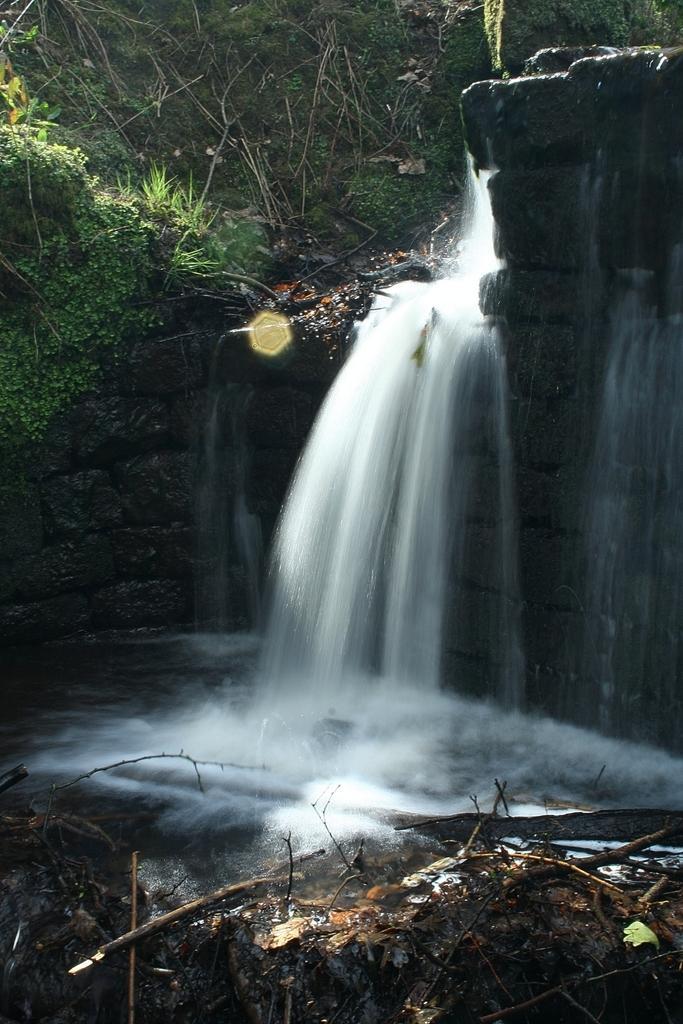Please provide a concise description of this image. In this image I can see a waterfall in the centre. On the bottom side of this image I can see few sticks and on the top of this image I can see grass. 